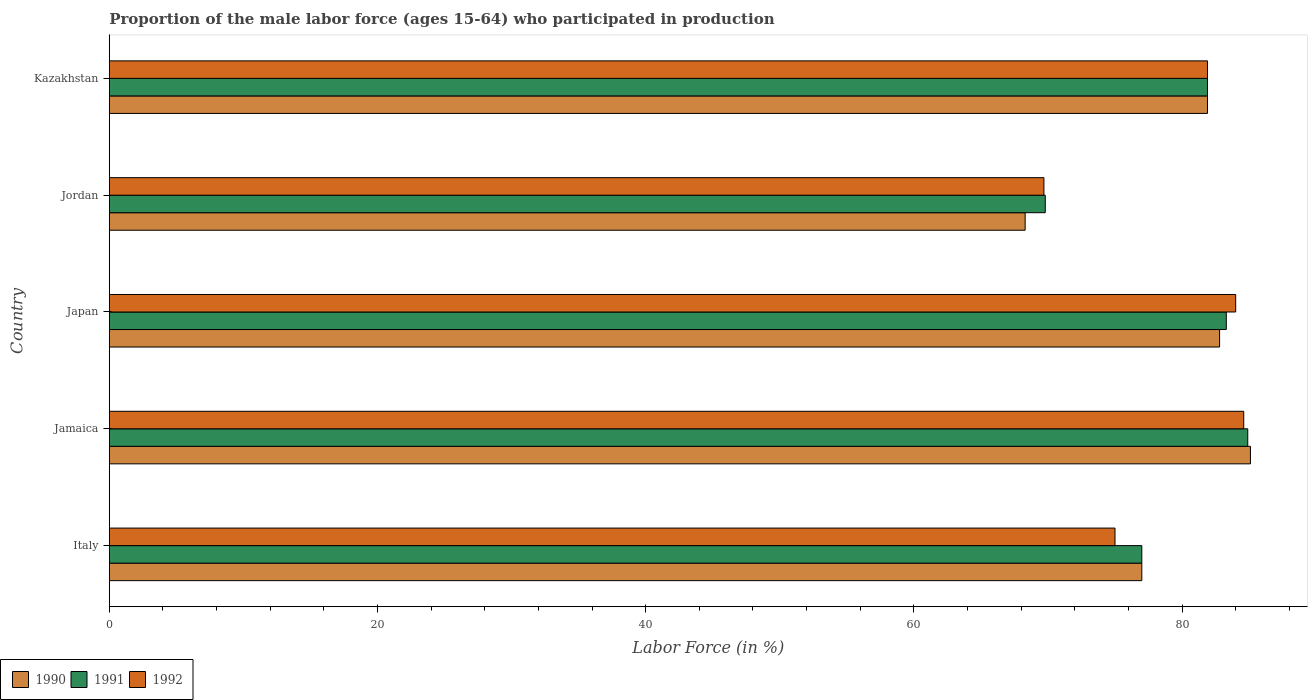How many groups of bars are there?
Give a very brief answer. 5. How many bars are there on the 5th tick from the top?
Your answer should be very brief. 3. How many bars are there on the 4th tick from the bottom?
Keep it short and to the point. 3. What is the label of the 5th group of bars from the top?
Keep it short and to the point. Italy. What is the proportion of the male labor force who participated in production in 1990 in Jamaica?
Your answer should be very brief. 85.1. Across all countries, what is the maximum proportion of the male labor force who participated in production in 1992?
Ensure brevity in your answer.  84.6. Across all countries, what is the minimum proportion of the male labor force who participated in production in 1992?
Keep it short and to the point. 69.7. In which country was the proportion of the male labor force who participated in production in 1992 maximum?
Your answer should be compact. Jamaica. In which country was the proportion of the male labor force who participated in production in 1992 minimum?
Your answer should be compact. Jordan. What is the total proportion of the male labor force who participated in production in 1990 in the graph?
Keep it short and to the point. 395.1. What is the difference between the proportion of the male labor force who participated in production in 1991 in Japan and that in Kazakhstan?
Ensure brevity in your answer.  1.4. What is the difference between the proportion of the male labor force who participated in production in 1990 in Japan and the proportion of the male labor force who participated in production in 1992 in Jamaica?
Offer a terse response. -1.8. What is the average proportion of the male labor force who participated in production in 1991 per country?
Offer a very short reply. 79.38. In how many countries, is the proportion of the male labor force who participated in production in 1991 greater than 12 %?
Your answer should be very brief. 5. What is the ratio of the proportion of the male labor force who participated in production in 1990 in Jamaica to that in Japan?
Provide a succinct answer. 1.03. Is the difference between the proportion of the male labor force who participated in production in 1992 in Jamaica and Japan greater than the difference between the proportion of the male labor force who participated in production in 1990 in Jamaica and Japan?
Provide a succinct answer. No. What is the difference between the highest and the second highest proportion of the male labor force who participated in production in 1992?
Your answer should be very brief. 0.6. What is the difference between the highest and the lowest proportion of the male labor force who participated in production in 1990?
Ensure brevity in your answer.  16.8. What does the 2nd bar from the bottom in Italy represents?
Ensure brevity in your answer.  1991. Is it the case that in every country, the sum of the proportion of the male labor force who participated in production in 1992 and proportion of the male labor force who participated in production in 1991 is greater than the proportion of the male labor force who participated in production in 1990?
Keep it short and to the point. Yes. Are all the bars in the graph horizontal?
Offer a very short reply. Yes. What is the difference between two consecutive major ticks on the X-axis?
Your answer should be compact. 20. Are the values on the major ticks of X-axis written in scientific E-notation?
Your response must be concise. No. Does the graph contain grids?
Your answer should be compact. No. How are the legend labels stacked?
Keep it short and to the point. Horizontal. What is the title of the graph?
Give a very brief answer. Proportion of the male labor force (ages 15-64) who participated in production. Does "1974" appear as one of the legend labels in the graph?
Ensure brevity in your answer.  No. What is the label or title of the X-axis?
Your response must be concise. Labor Force (in %). What is the label or title of the Y-axis?
Offer a very short reply. Country. What is the Labor Force (in %) in 1991 in Italy?
Ensure brevity in your answer.  77. What is the Labor Force (in %) of 1990 in Jamaica?
Keep it short and to the point. 85.1. What is the Labor Force (in %) of 1991 in Jamaica?
Offer a terse response. 84.9. What is the Labor Force (in %) of 1992 in Jamaica?
Ensure brevity in your answer.  84.6. What is the Labor Force (in %) in 1990 in Japan?
Make the answer very short. 82.8. What is the Labor Force (in %) in 1991 in Japan?
Offer a terse response. 83.3. What is the Labor Force (in %) of 1990 in Jordan?
Ensure brevity in your answer.  68.3. What is the Labor Force (in %) in 1991 in Jordan?
Keep it short and to the point. 69.8. What is the Labor Force (in %) of 1992 in Jordan?
Provide a succinct answer. 69.7. What is the Labor Force (in %) in 1990 in Kazakhstan?
Offer a terse response. 81.9. What is the Labor Force (in %) of 1991 in Kazakhstan?
Your answer should be compact. 81.9. What is the Labor Force (in %) of 1992 in Kazakhstan?
Your answer should be very brief. 81.9. Across all countries, what is the maximum Labor Force (in %) in 1990?
Your answer should be compact. 85.1. Across all countries, what is the maximum Labor Force (in %) in 1991?
Your answer should be very brief. 84.9. Across all countries, what is the maximum Labor Force (in %) of 1992?
Provide a succinct answer. 84.6. Across all countries, what is the minimum Labor Force (in %) of 1990?
Your answer should be compact. 68.3. Across all countries, what is the minimum Labor Force (in %) of 1991?
Give a very brief answer. 69.8. Across all countries, what is the minimum Labor Force (in %) in 1992?
Offer a terse response. 69.7. What is the total Labor Force (in %) of 1990 in the graph?
Provide a succinct answer. 395.1. What is the total Labor Force (in %) of 1991 in the graph?
Offer a terse response. 396.9. What is the total Labor Force (in %) in 1992 in the graph?
Your answer should be compact. 395.2. What is the difference between the Labor Force (in %) in 1991 in Italy and that in Jamaica?
Offer a very short reply. -7.9. What is the difference between the Labor Force (in %) in 1990 in Italy and that in Japan?
Your answer should be very brief. -5.8. What is the difference between the Labor Force (in %) of 1992 in Italy and that in Japan?
Ensure brevity in your answer.  -9. What is the difference between the Labor Force (in %) in 1990 in Italy and that in Jordan?
Your response must be concise. 8.7. What is the difference between the Labor Force (in %) of 1991 in Italy and that in Jordan?
Your response must be concise. 7.2. What is the difference between the Labor Force (in %) in 1992 in Italy and that in Jordan?
Give a very brief answer. 5.3. What is the difference between the Labor Force (in %) in 1992 in Italy and that in Kazakhstan?
Offer a very short reply. -6.9. What is the difference between the Labor Force (in %) of 1991 in Jamaica and that in Japan?
Your answer should be very brief. 1.6. What is the difference between the Labor Force (in %) in 1992 in Jamaica and that in Japan?
Keep it short and to the point. 0.6. What is the difference between the Labor Force (in %) of 1990 in Jamaica and that in Jordan?
Offer a terse response. 16.8. What is the difference between the Labor Force (in %) in 1991 in Jamaica and that in Kazakhstan?
Ensure brevity in your answer.  3. What is the difference between the Labor Force (in %) of 1990 in Japan and that in Jordan?
Provide a short and direct response. 14.5. What is the difference between the Labor Force (in %) of 1991 in Japan and that in Jordan?
Your response must be concise. 13.5. What is the difference between the Labor Force (in %) in 1992 in Japan and that in Jordan?
Make the answer very short. 14.3. What is the difference between the Labor Force (in %) of 1992 in Japan and that in Kazakhstan?
Your response must be concise. 2.1. What is the difference between the Labor Force (in %) in 1990 in Italy and the Labor Force (in %) in 1992 in Jamaica?
Your response must be concise. -7.6. What is the difference between the Labor Force (in %) of 1991 in Italy and the Labor Force (in %) of 1992 in Jamaica?
Your response must be concise. -7.6. What is the difference between the Labor Force (in %) in 1991 in Italy and the Labor Force (in %) in 1992 in Japan?
Provide a short and direct response. -7. What is the difference between the Labor Force (in %) of 1990 in Italy and the Labor Force (in %) of 1991 in Jordan?
Provide a short and direct response. 7.2. What is the difference between the Labor Force (in %) in 1990 in Italy and the Labor Force (in %) in 1991 in Kazakhstan?
Give a very brief answer. -4.9. What is the difference between the Labor Force (in %) of 1991 in Italy and the Labor Force (in %) of 1992 in Kazakhstan?
Your answer should be very brief. -4.9. What is the difference between the Labor Force (in %) in 1990 in Jamaica and the Labor Force (in %) in 1991 in Japan?
Your answer should be compact. 1.8. What is the difference between the Labor Force (in %) in 1990 in Jamaica and the Labor Force (in %) in 1992 in Jordan?
Make the answer very short. 15.4. What is the difference between the Labor Force (in %) of 1990 in Jamaica and the Labor Force (in %) of 1991 in Kazakhstan?
Provide a succinct answer. 3.2. What is the difference between the Labor Force (in %) in 1991 in Jamaica and the Labor Force (in %) in 1992 in Kazakhstan?
Your answer should be compact. 3. What is the difference between the Labor Force (in %) in 1990 in Japan and the Labor Force (in %) in 1991 in Jordan?
Provide a short and direct response. 13. What is the difference between the Labor Force (in %) of 1990 in Japan and the Labor Force (in %) of 1992 in Jordan?
Your response must be concise. 13.1. What is the difference between the Labor Force (in %) of 1991 in Japan and the Labor Force (in %) of 1992 in Jordan?
Offer a very short reply. 13.6. What is the difference between the Labor Force (in %) in 1990 in Japan and the Labor Force (in %) in 1991 in Kazakhstan?
Your response must be concise. 0.9. What is the difference between the Labor Force (in %) of 1990 in Japan and the Labor Force (in %) of 1992 in Kazakhstan?
Your answer should be compact. 0.9. What is the difference between the Labor Force (in %) of 1991 in Japan and the Labor Force (in %) of 1992 in Kazakhstan?
Your answer should be very brief. 1.4. What is the average Labor Force (in %) in 1990 per country?
Give a very brief answer. 79.02. What is the average Labor Force (in %) in 1991 per country?
Ensure brevity in your answer.  79.38. What is the average Labor Force (in %) of 1992 per country?
Ensure brevity in your answer.  79.04. What is the difference between the Labor Force (in %) of 1990 and Labor Force (in %) of 1991 in Italy?
Your answer should be compact. 0. What is the difference between the Labor Force (in %) of 1990 and Labor Force (in %) of 1992 in Italy?
Offer a very short reply. 2. What is the difference between the Labor Force (in %) in 1991 and Labor Force (in %) in 1992 in Italy?
Provide a short and direct response. 2. What is the difference between the Labor Force (in %) of 1990 and Labor Force (in %) of 1991 in Jamaica?
Offer a very short reply. 0.2. What is the difference between the Labor Force (in %) in 1990 and Labor Force (in %) in 1992 in Jamaica?
Make the answer very short. 0.5. What is the difference between the Labor Force (in %) in 1990 and Labor Force (in %) in 1991 in Japan?
Your answer should be compact. -0.5. What is the difference between the Labor Force (in %) in 1990 and Labor Force (in %) in 1992 in Jordan?
Your answer should be very brief. -1.4. What is the difference between the Labor Force (in %) in 1991 and Labor Force (in %) in 1992 in Jordan?
Provide a succinct answer. 0.1. What is the difference between the Labor Force (in %) in 1991 and Labor Force (in %) in 1992 in Kazakhstan?
Your answer should be compact. 0. What is the ratio of the Labor Force (in %) of 1990 in Italy to that in Jamaica?
Make the answer very short. 0.9. What is the ratio of the Labor Force (in %) of 1991 in Italy to that in Jamaica?
Provide a short and direct response. 0.91. What is the ratio of the Labor Force (in %) of 1992 in Italy to that in Jamaica?
Provide a succinct answer. 0.89. What is the ratio of the Labor Force (in %) in 1991 in Italy to that in Japan?
Provide a short and direct response. 0.92. What is the ratio of the Labor Force (in %) in 1992 in Italy to that in Japan?
Your answer should be compact. 0.89. What is the ratio of the Labor Force (in %) in 1990 in Italy to that in Jordan?
Your response must be concise. 1.13. What is the ratio of the Labor Force (in %) in 1991 in Italy to that in Jordan?
Your response must be concise. 1.1. What is the ratio of the Labor Force (in %) of 1992 in Italy to that in Jordan?
Ensure brevity in your answer.  1.08. What is the ratio of the Labor Force (in %) of 1990 in Italy to that in Kazakhstan?
Your answer should be compact. 0.94. What is the ratio of the Labor Force (in %) of 1991 in Italy to that in Kazakhstan?
Offer a very short reply. 0.94. What is the ratio of the Labor Force (in %) of 1992 in Italy to that in Kazakhstan?
Provide a succinct answer. 0.92. What is the ratio of the Labor Force (in %) of 1990 in Jamaica to that in Japan?
Offer a terse response. 1.03. What is the ratio of the Labor Force (in %) in 1991 in Jamaica to that in Japan?
Keep it short and to the point. 1.02. What is the ratio of the Labor Force (in %) of 1992 in Jamaica to that in Japan?
Offer a very short reply. 1.01. What is the ratio of the Labor Force (in %) in 1990 in Jamaica to that in Jordan?
Your answer should be very brief. 1.25. What is the ratio of the Labor Force (in %) in 1991 in Jamaica to that in Jordan?
Make the answer very short. 1.22. What is the ratio of the Labor Force (in %) in 1992 in Jamaica to that in Jordan?
Ensure brevity in your answer.  1.21. What is the ratio of the Labor Force (in %) in 1990 in Jamaica to that in Kazakhstan?
Offer a terse response. 1.04. What is the ratio of the Labor Force (in %) in 1991 in Jamaica to that in Kazakhstan?
Offer a terse response. 1.04. What is the ratio of the Labor Force (in %) in 1992 in Jamaica to that in Kazakhstan?
Provide a short and direct response. 1.03. What is the ratio of the Labor Force (in %) of 1990 in Japan to that in Jordan?
Make the answer very short. 1.21. What is the ratio of the Labor Force (in %) of 1991 in Japan to that in Jordan?
Offer a terse response. 1.19. What is the ratio of the Labor Force (in %) in 1992 in Japan to that in Jordan?
Make the answer very short. 1.21. What is the ratio of the Labor Force (in %) in 1991 in Japan to that in Kazakhstan?
Your answer should be compact. 1.02. What is the ratio of the Labor Force (in %) of 1992 in Japan to that in Kazakhstan?
Your answer should be very brief. 1.03. What is the ratio of the Labor Force (in %) of 1990 in Jordan to that in Kazakhstan?
Offer a terse response. 0.83. What is the ratio of the Labor Force (in %) in 1991 in Jordan to that in Kazakhstan?
Your response must be concise. 0.85. What is the ratio of the Labor Force (in %) of 1992 in Jordan to that in Kazakhstan?
Keep it short and to the point. 0.85. What is the difference between the highest and the second highest Labor Force (in %) in 1992?
Provide a short and direct response. 0.6. What is the difference between the highest and the lowest Labor Force (in %) of 1990?
Keep it short and to the point. 16.8. What is the difference between the highest and the lowest Labor Force (in %) in 1992?
Provide a short and direct response. 14.9. 